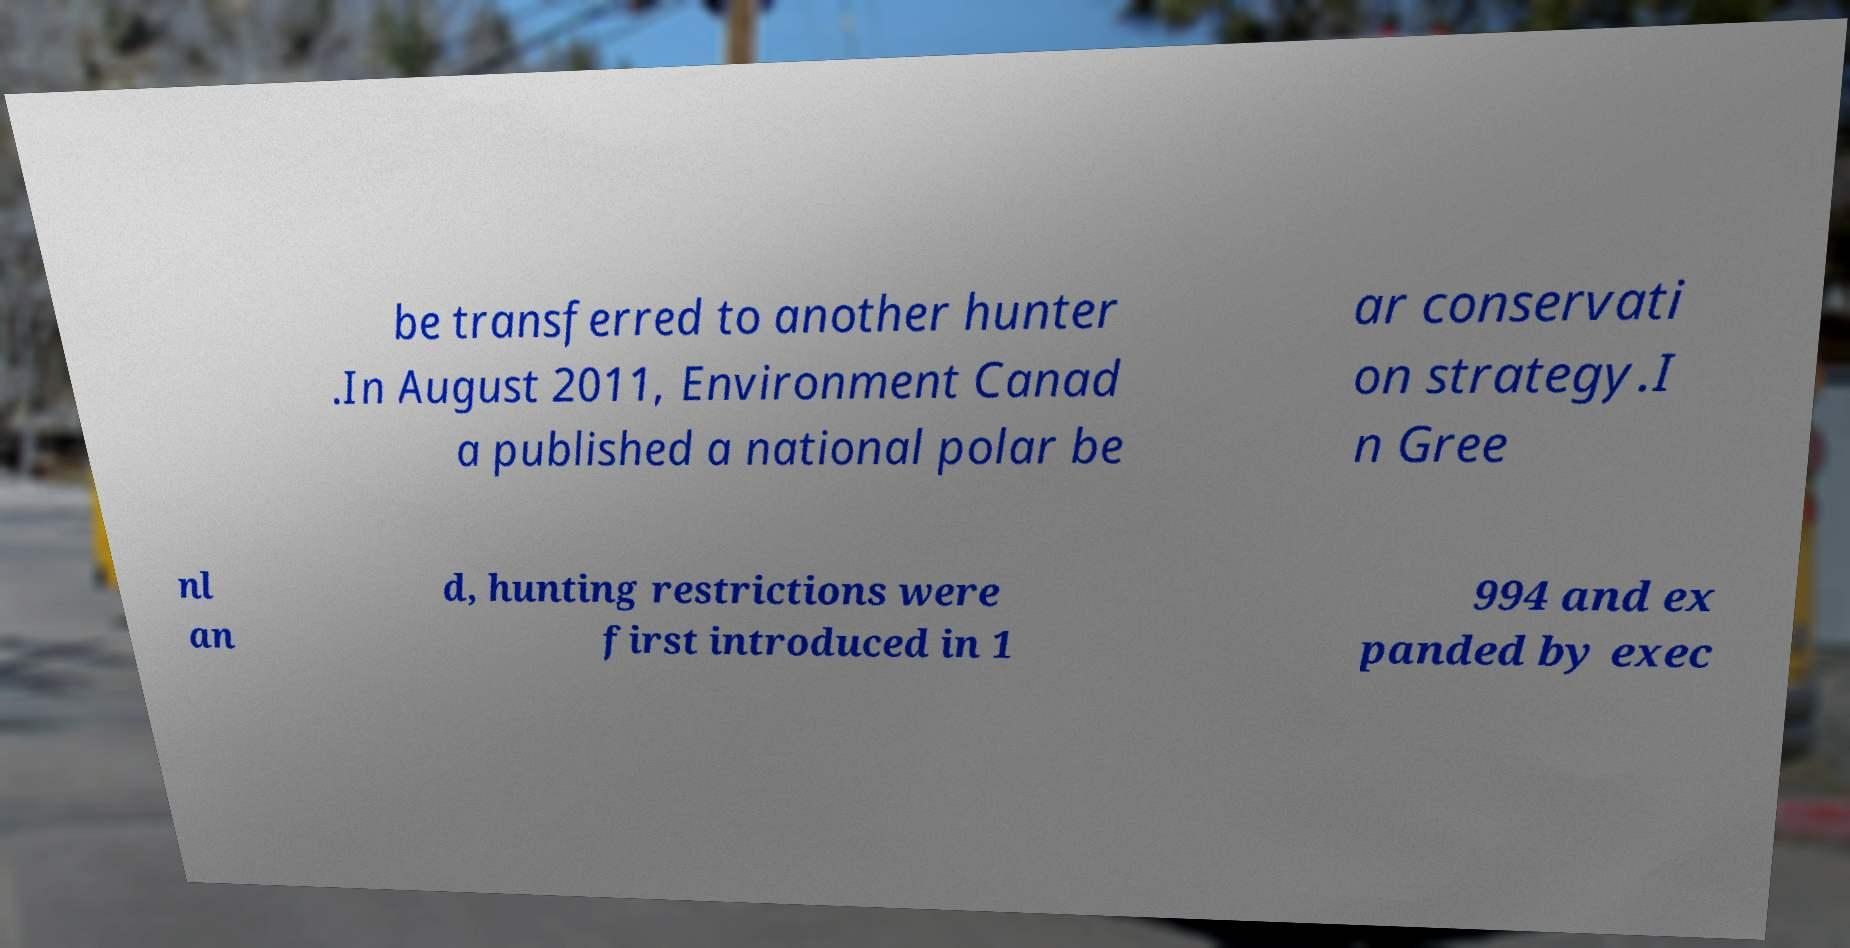For documentation purposes, I need the text within this image transcribed. Could you provide that? be transferred to another hunter .In August 2011, Environment Canad a published a national polar be ar conservati on strategy.I n Gree nl an d, hunting restrictions were first introduced in 1 994 and ex panded by exec 